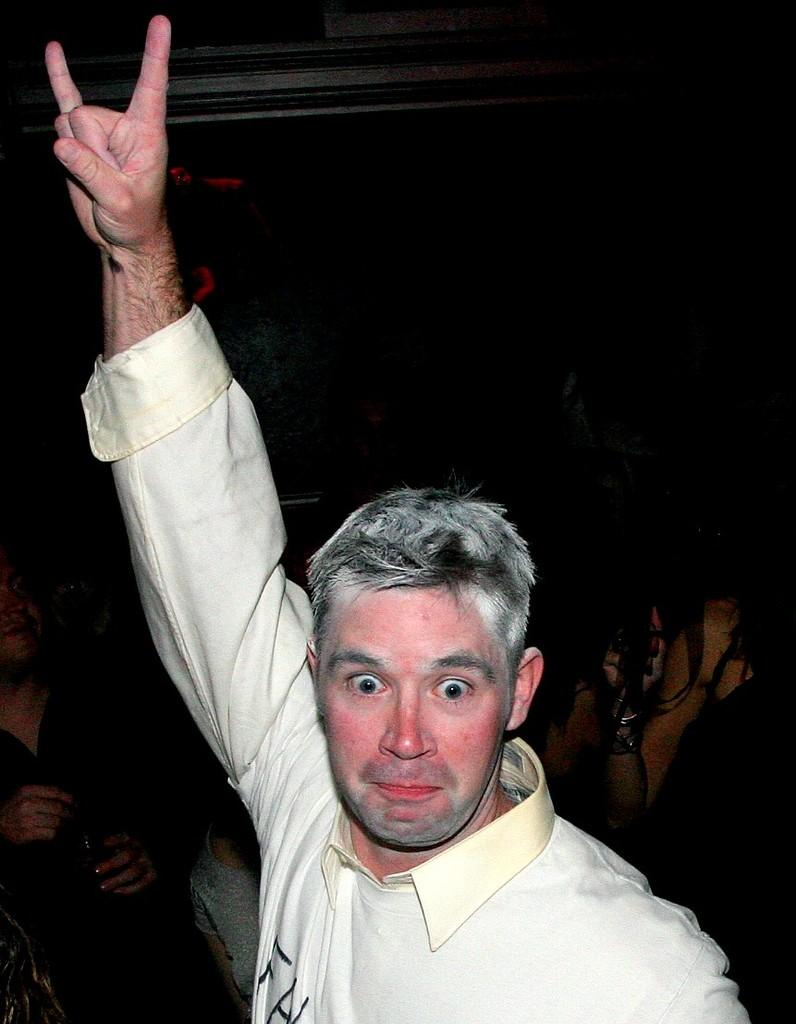What is the main subject of the image? A man is in the image. What is the man doing with his right hand? The man is raising his right hand. What type of clothing is the man wearing on his upper body? The man is wearing a t-shirt and a shirt. How many cakes does the man have on his legs in the image? There are no cakes present in the image, and the man's legs are not mentioned in the provided facts. 